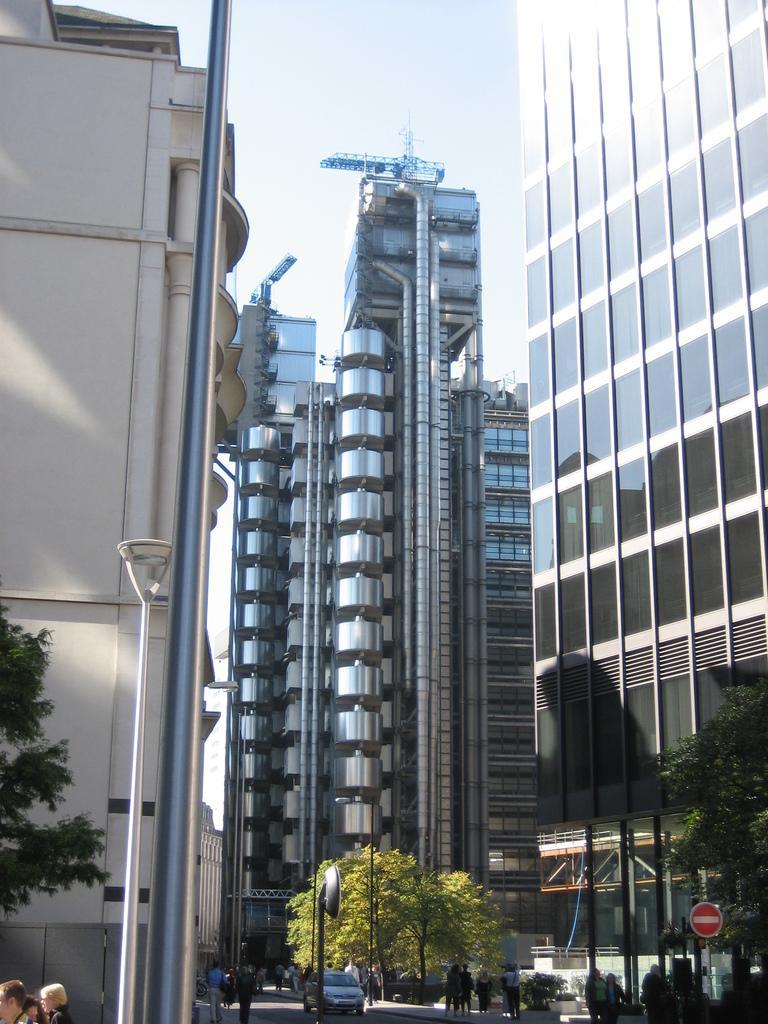How would you summarize this image in a sentence or two? In this image we can see a few buildings, there are some poles, trees, people, boards, plants and a light, in the background, we can see the sky. 